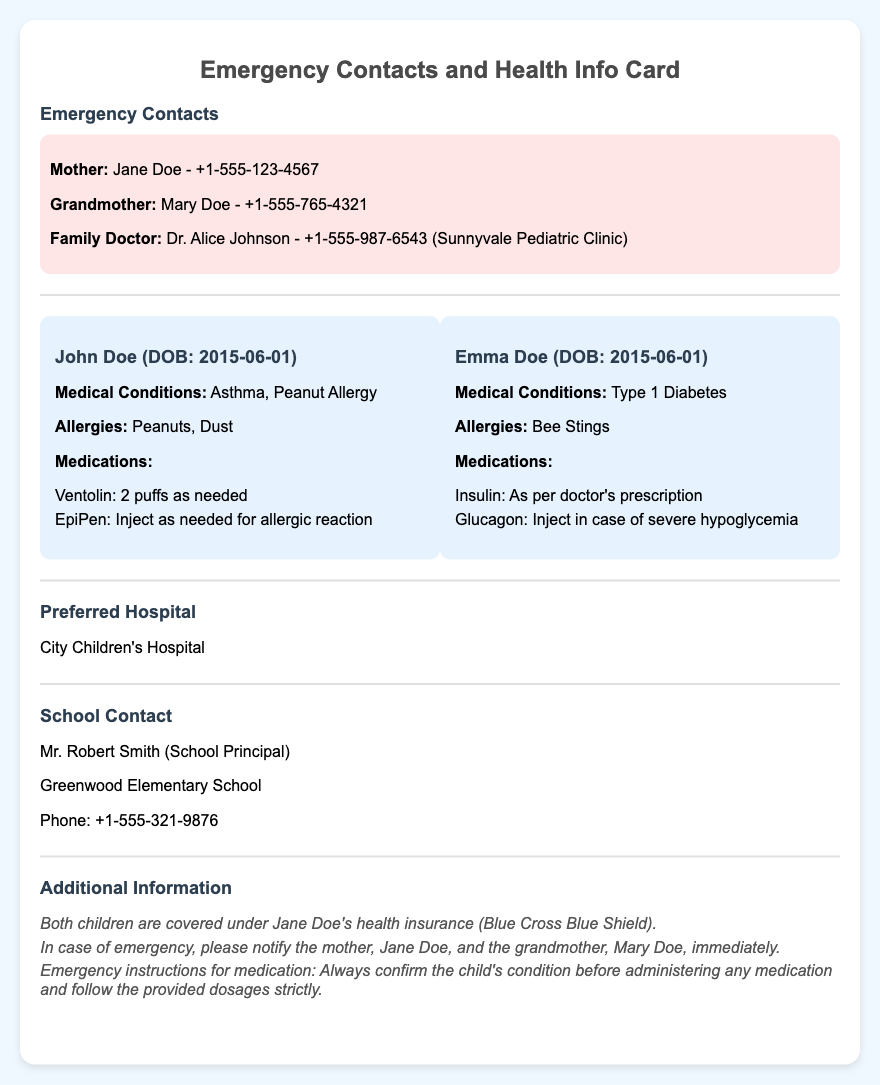What is the mother's name? The mother's name is provided in the emergency contacts section of the document.
Answer: Jane Doe What are John's allergies? John's allergies are listed under his specific child information section.
Answer: Peanuts, Dust Who is the family doctor? The family doctor is mentioned in the emergency contacts section, along with a phone number.
Answer: Dr. Alice Johnson What medical condition does Emma have? Emma's medical condition is explicitly stated in her section of the child information.
Answer: Type 1 Diabetes What is the preferred hospital? The preferred hospital is provided in a dedicated section of the document.
Answer: City Children's Hospital How many medications does John have listed? The number of medications is indicated in John's child information section.
Answer: 2 What is the school's contact person's name? The name of the school's contact person is mentioned in the school contact section of the document.
Answer: Mr. Robert Smith What should be done in case of an emergency? The emergency instructions are stated in the additional information section.
Answer: Notify the mother and grandmother immediately What type of insurance do both children have? The insurance coverage is specified in the additional information section.
Answer: Blue Cross Blue Shield 